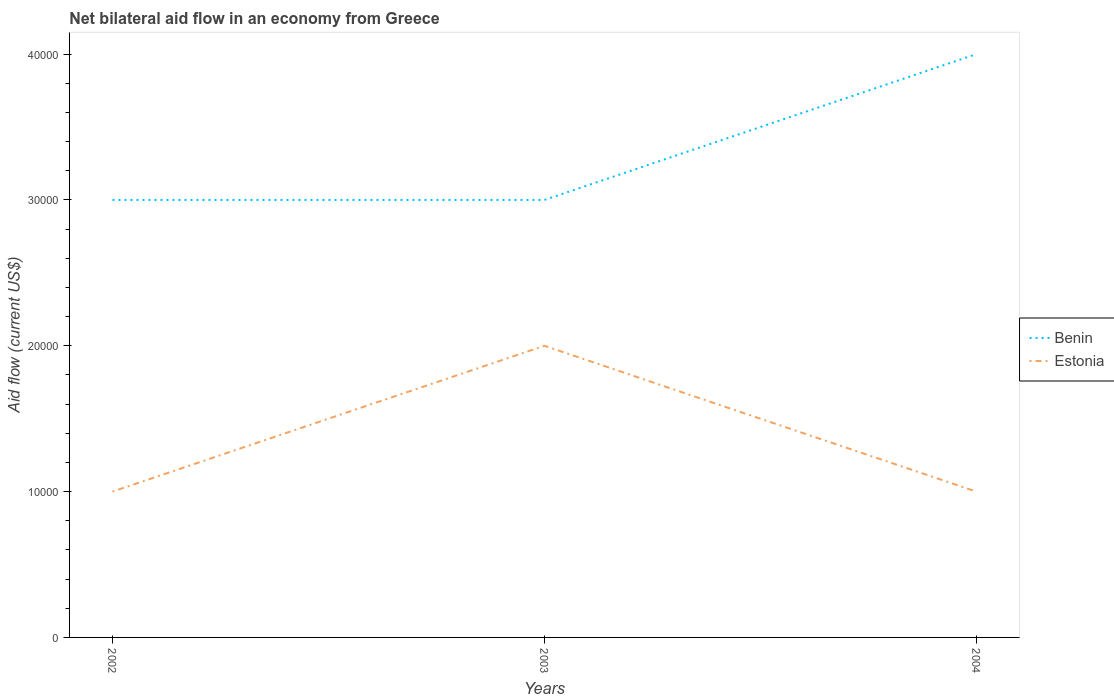How many different coloured lines are there?
Your response must be concise. 2. Does the line corresponding to Estonia intersect with the line corresponding to Benin?
Provide a succinct answer. No. In which year was the net bilateral aid flow in Estonia maximum?
Provide a succinct answer. 2002. What is the total net bilateral aid flow in Benin in the graph?
Ensure brevity in your answer.  -10000. Is the net bilateral aid flow in Estonia strictly greater than the net bilateral aid flow in Benin over the years?
Offer a terse response. Yes. How many lines are there?
Provide a short and direct response. 2. How many years are there in the graph?
Offer a terse response. 3. What is the difference between two consecutive major ticks on the Y-axis?
Offer a terse response. 10000. Are the values on the major ticks of Y-axis written in scientific E-notation?
Make the answer very short. No. Does the graph contain any zero values?
Your response must be concise. No. Does the graph contain grids?
Give a very brief answer. No. How many legend labels are there?
Provide a short and direct response. 2. What is the title of the graph?
Offer a very short reply. Net bilateral aid flow in an economy from Greece. Does "Mongolia" appear as one of the legend labels in the graph?
Give a very brief answer. No. What is the Aid flow (current US$) of Benin in 2002?
Your answer should be very brief. 3.00e+04. What is the Aid flow (current US$) of Estonia in 2002?
Provide a succinct answer. 10000. What is the Aid flow (current US$) of Benin in 2004?
Keep it short and to the point. 4.00e+04. What is the Aid flow (current US$) in Estonia in 2004?
Provide a short and direct response. 10000. Across all years, what is the minimum Aid flow (current US$) of Estonia?
Ensure brevity in your answer.  10000. What is the total Aid flow (current US$) of Estonia in the graph?
Offer a very short reply. 4.00e+04. What is the difference between the Aid flow (current US$) in Benin in 2002 and that in 2003?
Offer a terse response. 0. What is the difference between the Aid flow (current US$) of Estonia in 2002 and that in 2003?
Keep it short and to the point. -10000. What is the difference between the Aid flow (current US$) in Benin in 2002 and that in 2004?
Provide a succinct answer. -10000. What is the difference between the Aid flow (current US$) of Benin in 2003 and that in 2004?
Offer a very short reply. -10000. What is the difference between the Aid flow (current US$) in Benin in 2002 and the Aid flow (current US$) in Estonia in 2003?
Make the answer very short. 10000. What is the difference between the Aid flow (current US$) in Benin in 2002 and the Aid flow (current US$) in Estonia in 2004?
Ensure brevity in your answer.  2.00e+04. What is the average Aid flow (current US$) of Benin per year?
Provide a short and direct response. 3.33e+04. What is the average Aid flow (current US$) of Estonia per year?
Your answer should be compact. 1.33e+04. In the year 2002, what is the difference between the Aid flow (current US$) in Benin and Aid flow (current US$) in Estonia?
Your answer should be very brief. 2.00e+04. In the year 2003, what is the difference between the Aid flow (current US$) of Benin and Aid flow (current US$) of Estonia?
Ensure brevity in your answer.  10000. In the year 2004, what is the difference between the Aid flow (current US$) of Benin and Aid flow (current US$) of Estonia?
Provide a short and direct response. 3.00e+04. What is the ratio of the Aid flow (current US$) in Benin in 2002 to that in 2003?
Offer a very short reply. 1. What is the ratio of the Aid flow (current US$) of Estonia in 2002 to that in 2003?
Your answer should be compact. 0.5. What is the ratio of the Aid flow (current US$) in Benin in 2002 to that in 2004?
Make the answer very short. 0.75. What is the ratio of the Aid flow (current US$) in Estonia in 2002 to that in 2004?
Provide a short and direct response. 1. What is the ratio of the Aid flow (current US$) of Benin in 2003 to that in 2004?
Provide a succinct answer. 0.75. What is the ratio of the Aid flow (current US$) of Estonia in 2003 to that in 2004?
Make the answer very short. 2. What is the difference between the highest and the second highest Aid flow (current US$) of Estonia?
Offer a very short reply. 10000. What is the difference between the highest and the lowest Aid flow (current US$) of Benin?
Ensure brevity in your answer.  10000. 